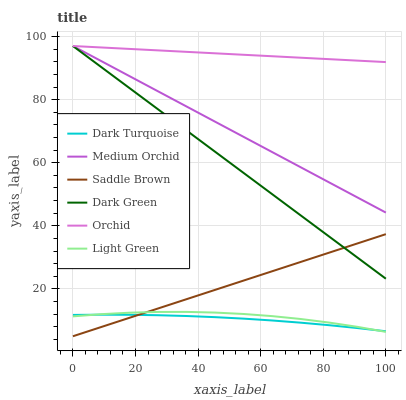Does Dark Turquoise have the minimum area under the curve?
Answer yes or no. Yes. Does Orchid have the maximum area under the curve?
Answer yes or no. Yes. Does Medium Orchid have the minimum area under the curve?
Answer yes or no. No. Does Medium Orchid have the maximum area under the curve?
Answer yes or no. No. Is Orchid the smoothest?
Answer yes or no. Yes. Is Light Green the roughest?
Answer yes or no. Yes. Is Medium Orchid the smoothest?
Answer yes or no. No. Is Medium Orchid the roughest?
Answer yes or no. No. Does Saddle Brown have the lowest value?
Answer yes or no. Yes. Does Medium Orchid have the lowest value?
Answer yes or no. No. Does Orchid have the highest value?
Answer yes or no. Yes. Does Light Green have the highest value?
Answer yes or no. No. Is Dark Turquoise less than Orchid?
Answer yes or no. Yes. Is Dark Green greater than Light Green?
Answer yes or no. Yes. Does Medium Orchid intersect Dark Green?
Answer yes or no. Yes. Is Medium Orchid less than Dark Green?
Answer yes or no. No. Is Medium Orchid greater than Dark Green?
Answer yes or no. No. Does Dark Turquoise intersect Orchid?
Answer yes or no. No. 